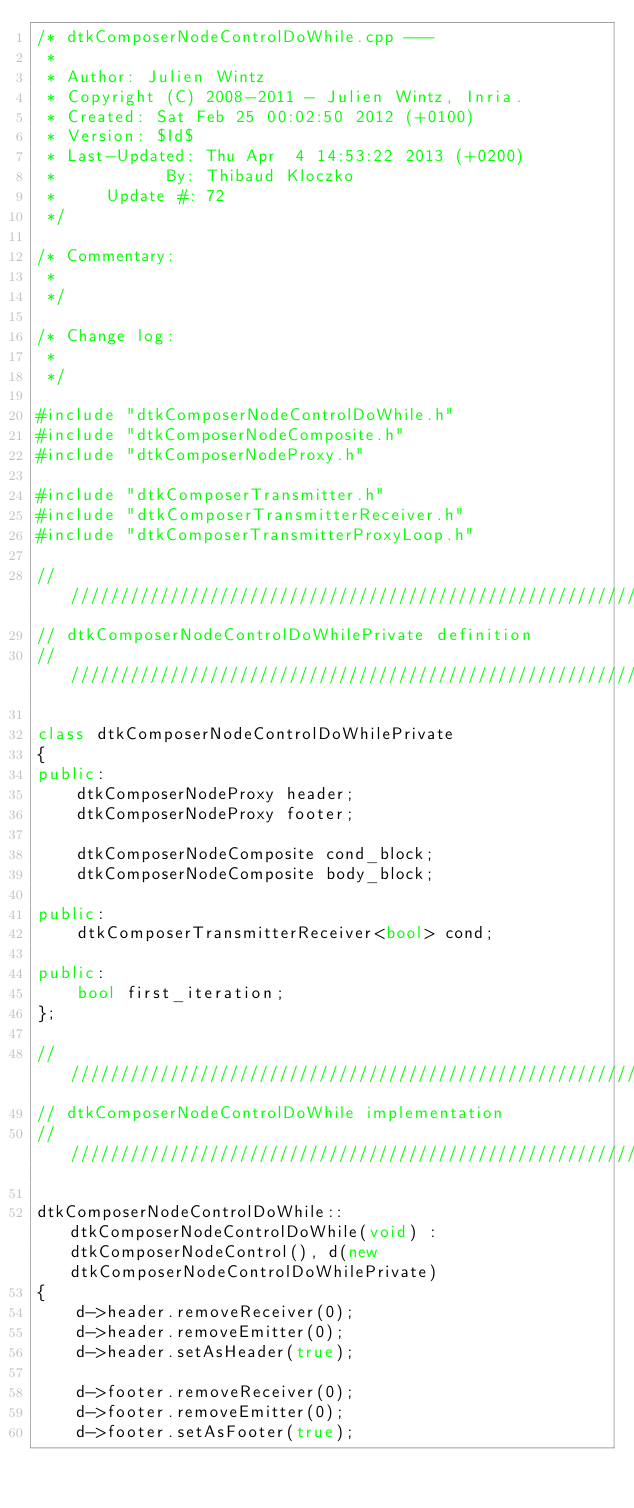Convert code to text. <code><loc_0><loc_0><loc_500><loc_500><_C++_>/* dtkComposerNodeControlDoWhile.cpp --- 
 * 
 * Author: Julien Wintz
 * Copyright (C) 2008-2011 - Julien Wintz, Inria.
 * Created: Sat Feb 25 00:02:50 2012 (+0100)
 * Version: $Id$
 * Last-Updated: Thu Apr  4 14:53:22 2013 (+0200)
 *           By: Thibaud Kloczko
 *     Update #: 72
 */

/* Commentary: 
 * 
 */

/* Change log:
 * 
 */

#include "dtkComposerNodeControlDoWhile.h"
#include "dtkComposerNodeComposite.h"
#include "dtkComposerNodeProxy.h"

#include "dtkComposerTransmitter.h"
#include "dtkComposerTransmitterReceiver.h"
#include "dtkComposerTransmitterProxyLoop.h"

// /////////////////////////////////////////////////////////////////
// dtkComposerNodeControlDoWhilePrivate definition
// /////////////////////////////////////////////////////////////////

class dtkComposerNodeControlDoWhilePrivate
{
public:
    dtkComposerNodeProxy header;
    dtkComposerNodeProxy footer;

    dtkComposerNodeComposite cond_block;
    dtkComposerNodeComposite body_block;

public:
    dtkComposerTransmitterReceiver<bool> cond;

public:
    bool first_iteration;
};

// /////////////////////////////////////////////////////////////////
// dtkComposerNodeControlDoWhile implementation
// /////////////////////////////////////////////////////////////////

dtkComposerNodeControlDoWhile::dtkComposerNodeControlDoWhile(void) : dtkComposerNodeControl(), d(new dtkComposerNodeControlDoWhilePrivate)
{
    d->header.removeReceiver(0);
    d->header.removeEmitter(0);
    d->header.setAsHeader(true);

    d->footer.removeReceiver(0);
    d->footer.removeEmitter(0);
    d->footer.setAsFooter(true);
</code> 